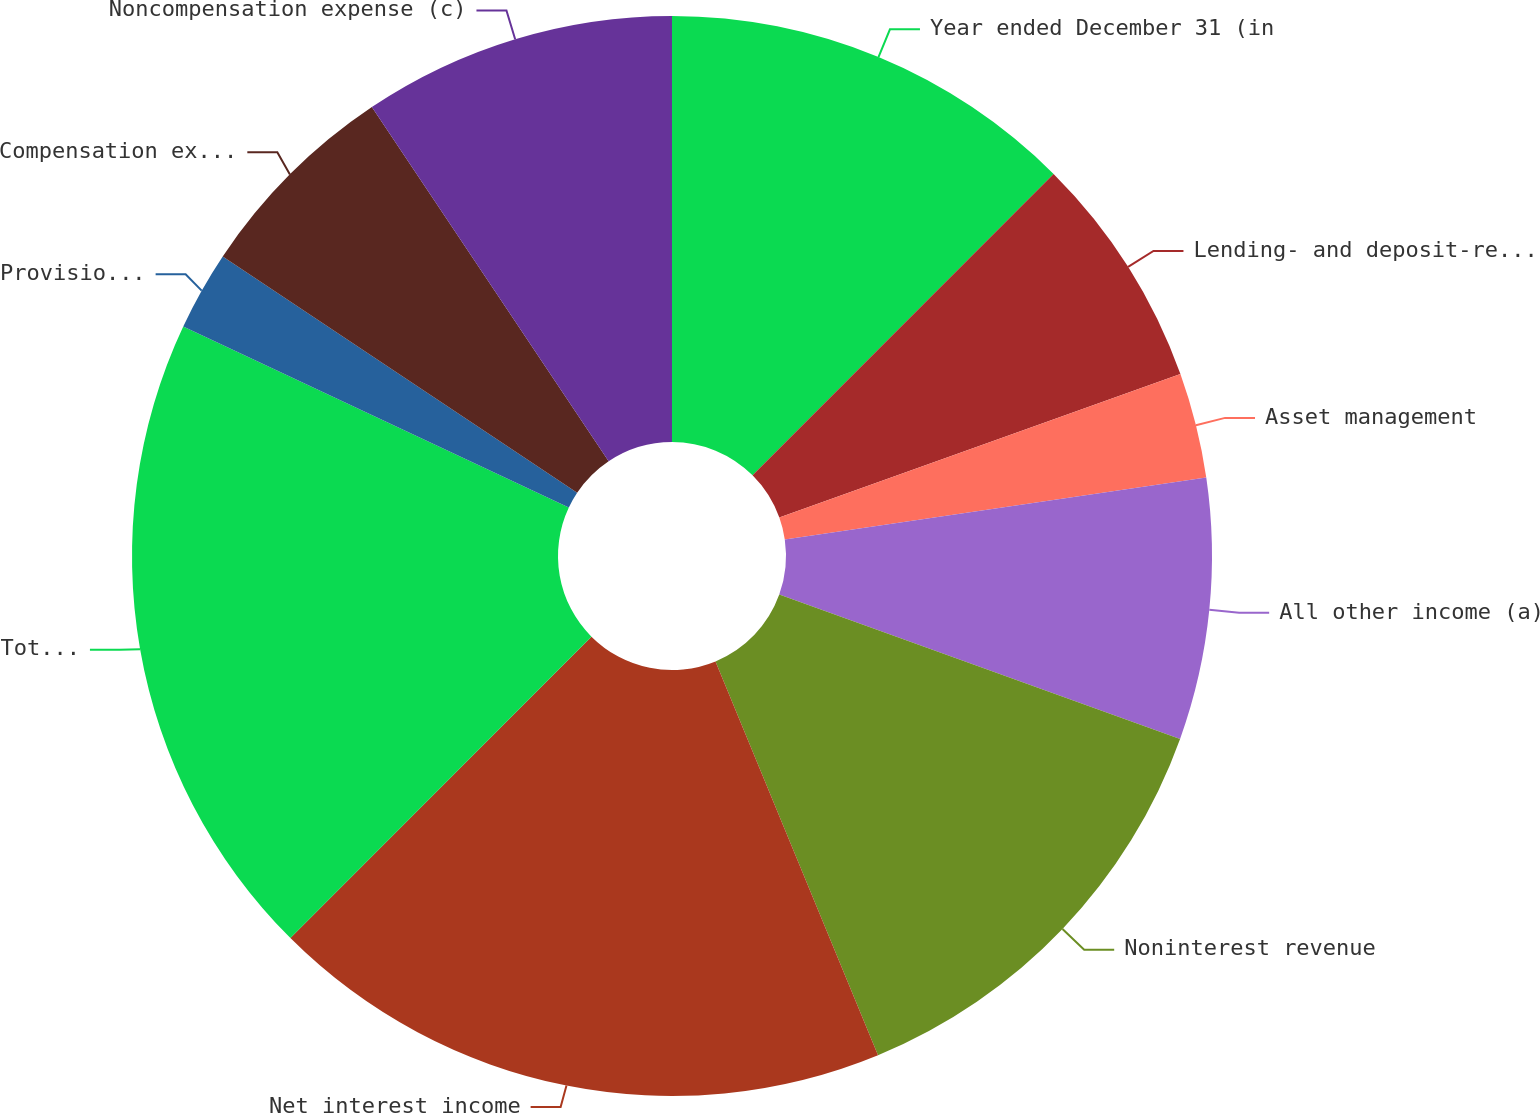<chart> <loc_0><loc_0><loc_500><loc_500><pie_chart><fcel>Year ended December 31 (in<fcel>Lending- and deposit-related<fcel>Asset management<fcel>All other income (a)<fcel>Noninterest revenue<fcel>Net interest income<fcel>Total net revenue (b)<fcel>Provision for credit losses<fcel>Compensation expense (c)<fcel>Noncompensation expense (c)<nl><fcel>12.49%<fcel>7.04%<fcel>3.15%<fcel>7.82%<fcel>13.27%<fcel>18.72%<fcel>19.5%<fcel>2.37%<fcel>6.26%<fcel>9.38%<nl></chart> 